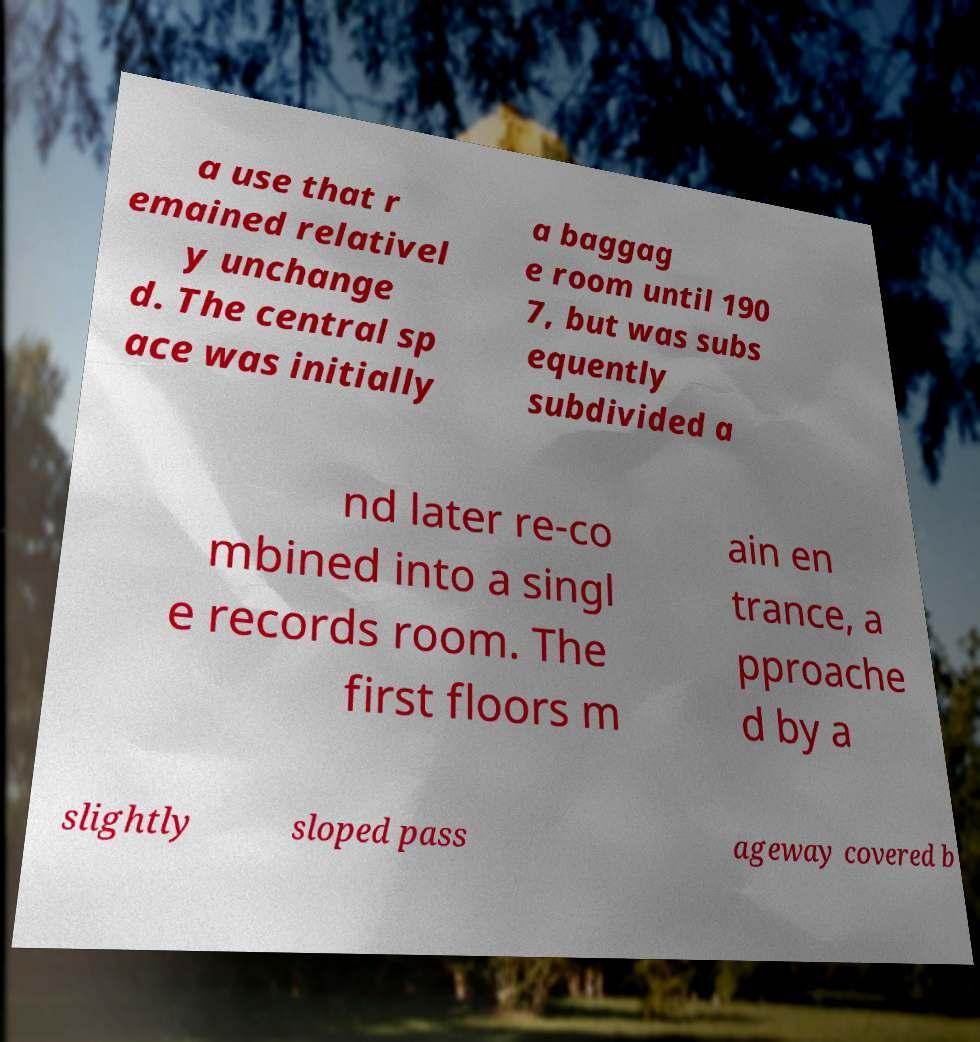Please read and relay the text visible in this image. What does it say? a use that r emained relativel y unchange d. The central sp ace was initially a baggag e room until 190 7, but was subs equently subdivided a nd later re-co mbined into a singl e records room. The first floors m ain en trance, a pproache d by a slightly sloped pass ageway covered b 